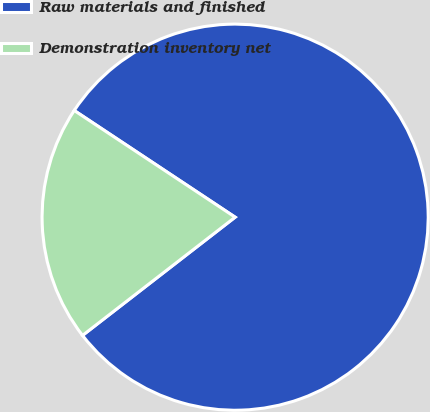Convert chart. <chart><loc_0><loc_0><loc_500><loc_500><pie_chart><fcel>Raw materials and finished<fcel>Demonstration inventory net<nl><fcel>80.19%<fcel>19.81%<nl></chart> 